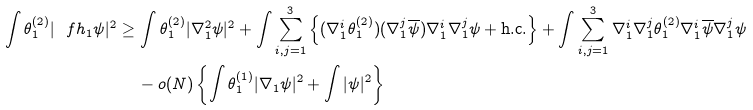Convert formula to latex. <formula><loc_0><loc_0><loc_500><loc_500>\int \theta _ { 1 } ^ { ( 2 ) } | \ f h _ { 1 } \psi | ^ { 2 } \geq \, & \int \theta _ { 1 } ^ { ( 2 ) } | \nabla _ { 1 } ^ { 2 } \psi | ^ { 2 } + \int \sum _ { i , j = 1 } ^ { 3 } \left \{ ( \nabla _ { 1 } ^ { i } \theta _ { 1 } ^ { ( 2 ) } ) ( \nabla _ { 1 } ^ { j } \overline { \psi } ) \nabla _ { 1 } ^ { i } \nabla _ { 1 } ^ { j } \psi + \text {h.c.} \right \} + \int \sum _ { i , j = 1 } ^ { 3 } \nabla _ { 1 } ^ { i } \nabla _ { 1 } ^ { j } \theta _ { 1 } ^ { ( 2 ) } \nabla _ { 1 } ^ { i } \overline { \psi } \nabla _ { 1 } ^ { j } \psi \, \\ & - o ( N ) \left \{ \int \theta _ { 1 } ^ { ( 1 ) } | \nabla _ { 1 } \psi | ^ { 2 } + \int | \psi | ^ { 2 } \right \}</formula> 